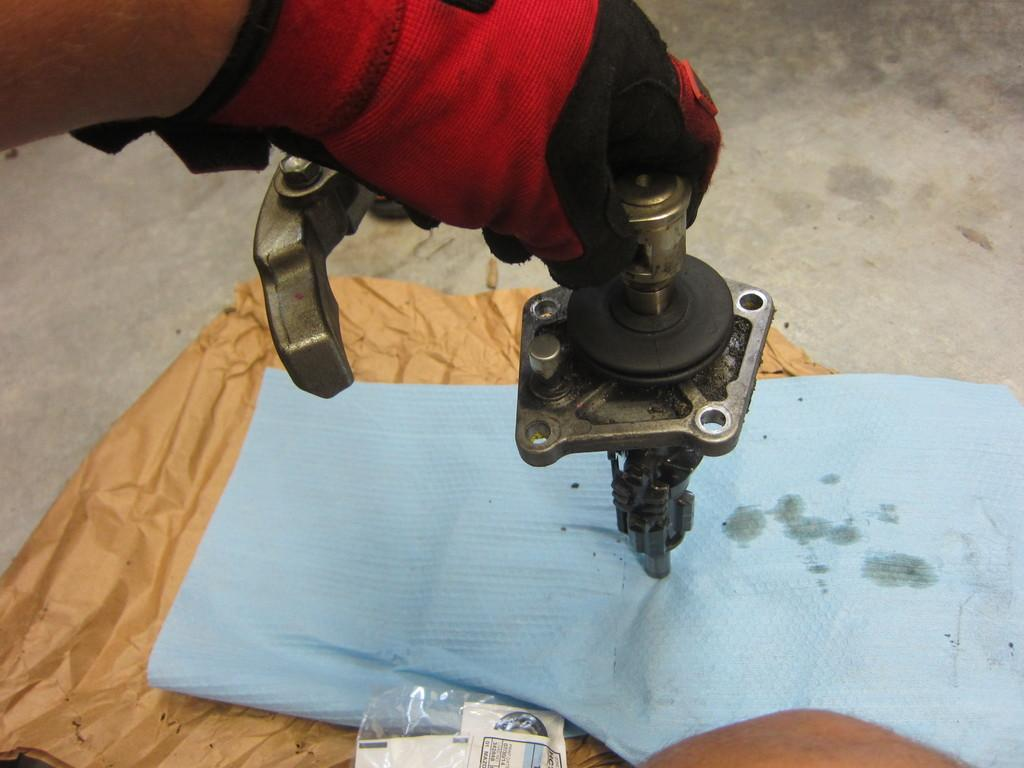What part of a person can be seen in the image? A person's hand is visible in the image. What is the person holding in the image? The person is holding a machine in the image. What is the machine placed on? The machine is on covers in the image. Where are the covers located? The covers are on the land in the image. What type of bee can be seen buzzing around the machine in the image? There are no bees present in the image; it only features a person's hand holding a machine on covers. 